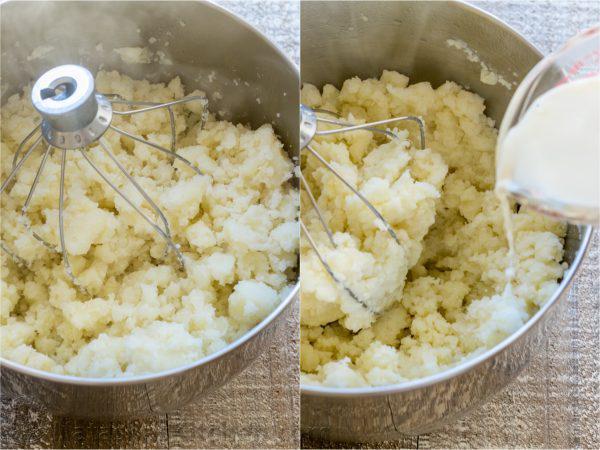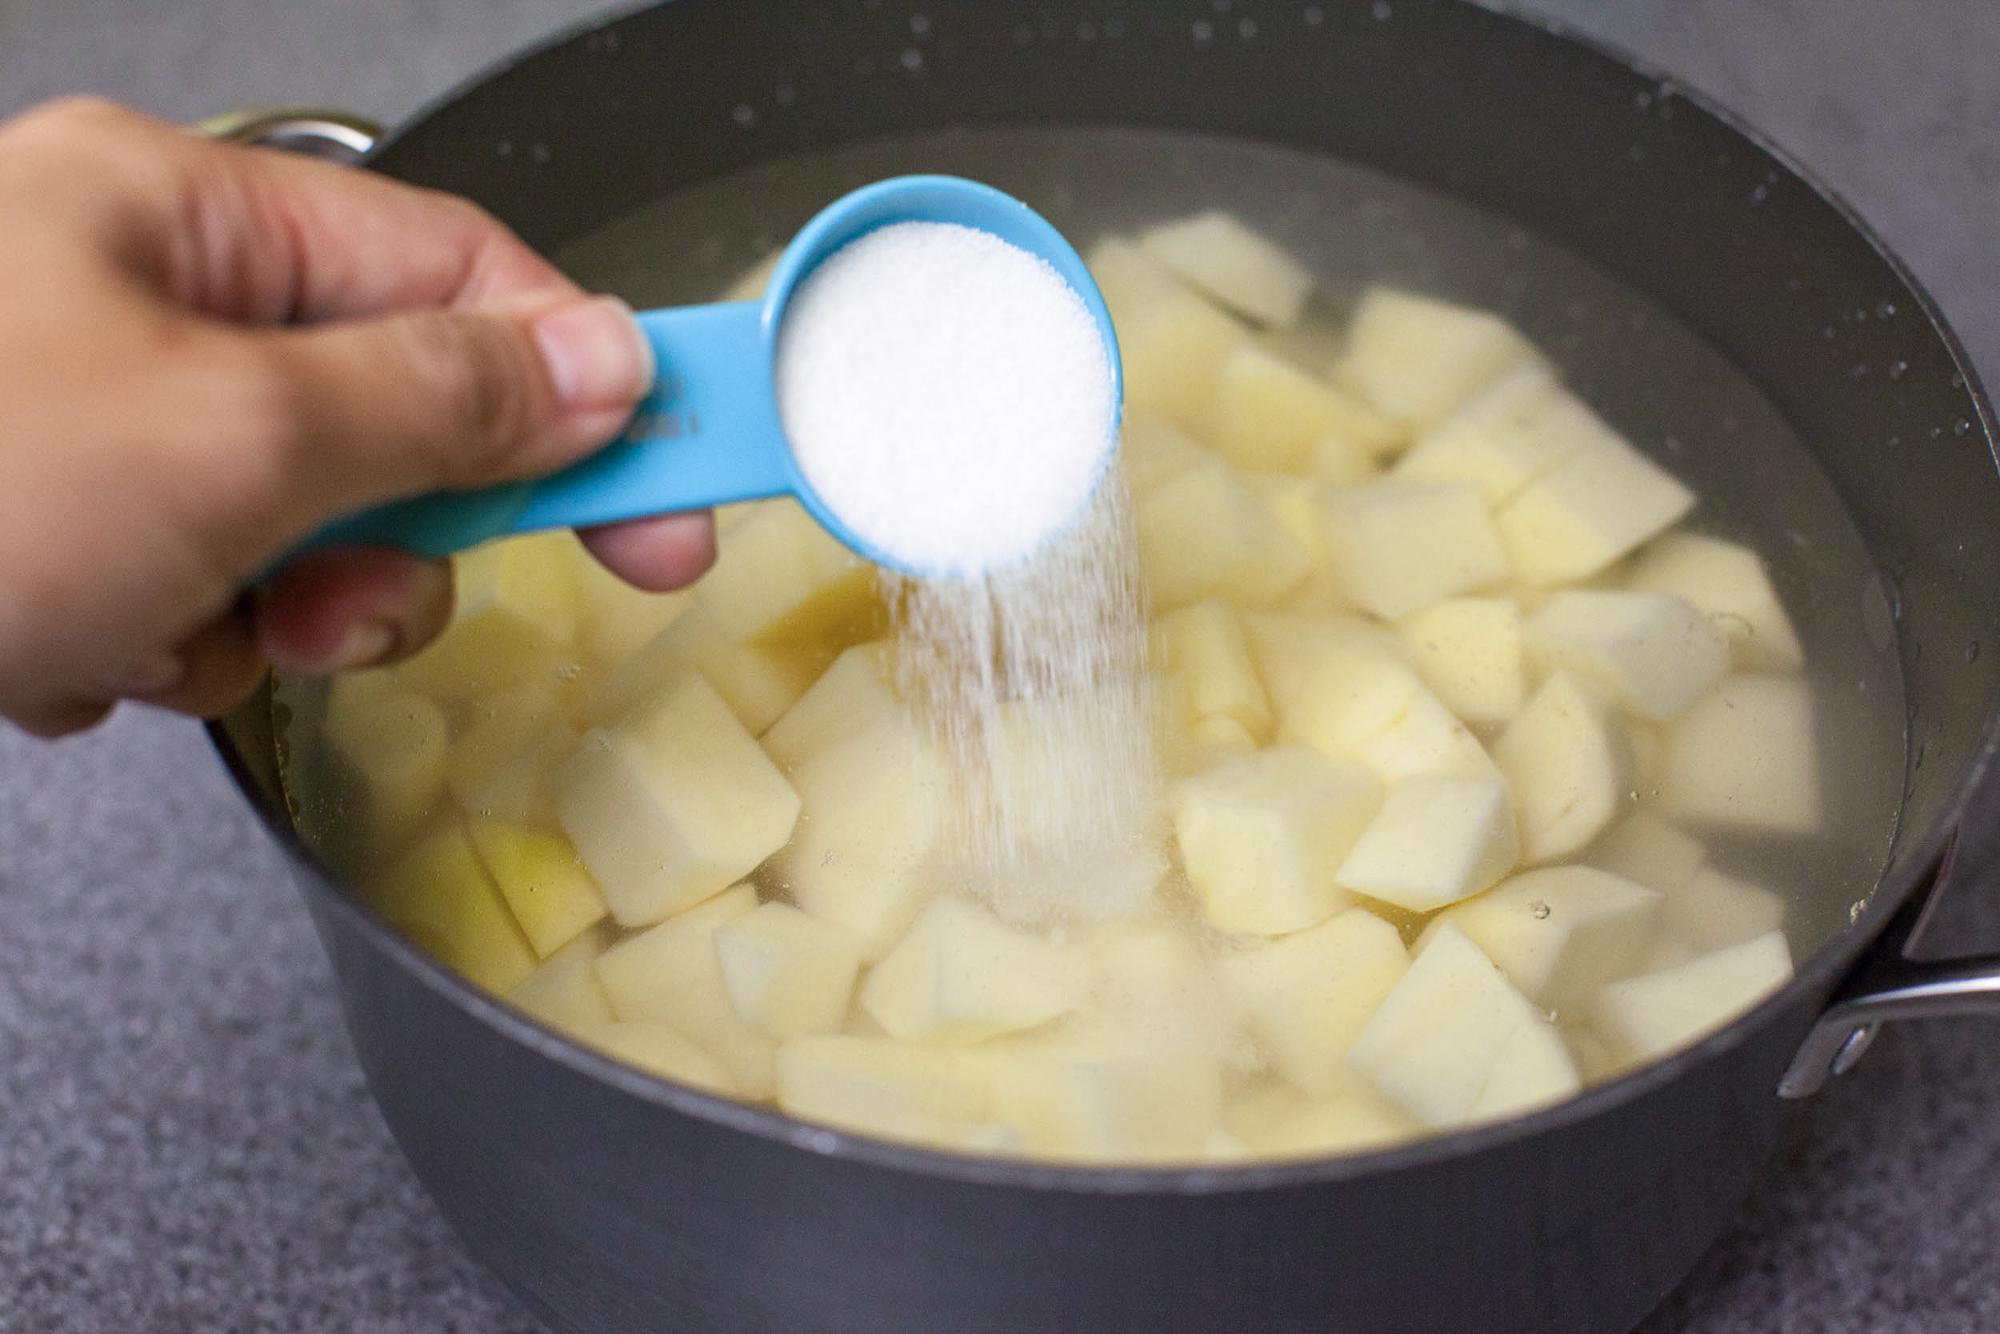The first image is the image on the left, the second image is the image on the right. For the images displayed, is the sentence "One image shows potatoes in a pot of water before boiling." factually correct? Answer yes or no. Yes. 